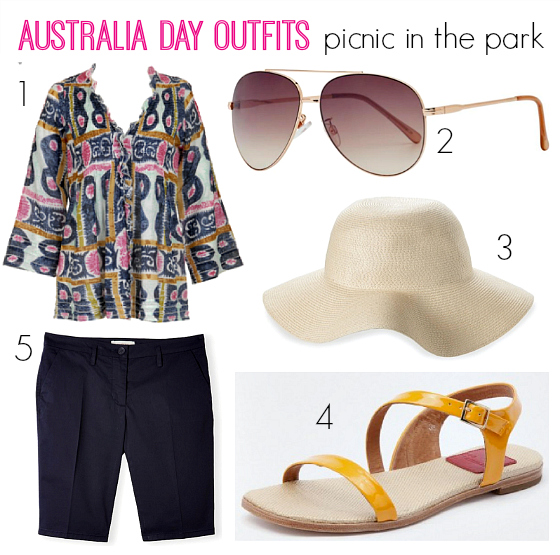Could the sun hat be paired effectively with item number 4 from the image? Absolutely, the sand-tone sun hat would pair beautifully with the colorful strappy sandals (item number 4). The neutral color of the hat balances the vivid hues of the sandals, creating a playful yet balanced summer look. This pairing would be perfect for casual outings like a seaside walk or a summer festival. 